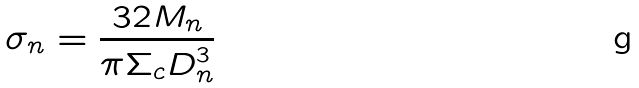Convert formula to latex. <formula><loc_0><loc_0><loc_500><loc_500>\sigma _ { n } = \frac { 3 2 M _ { n } } { \pi \Sigma _ { c } D _ { n } ^ { 3 } }</formula> 